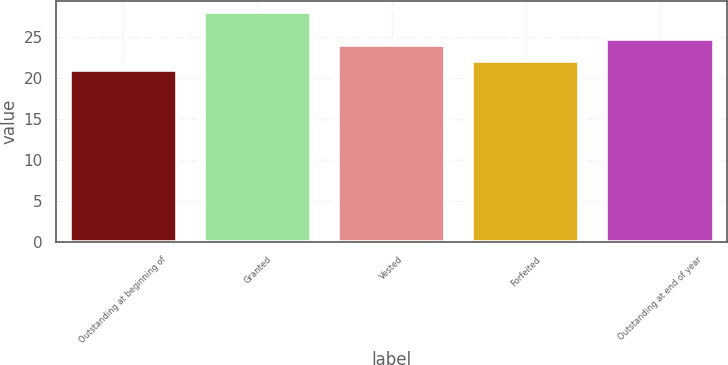<chart> <loc_0><loc_0><loc_500><loc_500><bar_chart><fcel>Outstanding at beginning of<fcel>Granted<fcel>Vested<fcel>Forfeited<fcel>Outstanding at end of year<nl><fcel>21<fcel>28<fcel>24<fcel>22<fcel>24.7<nl></chart> 